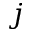Convert formula to latex. <formula><loc_0><loc_0><loc_500><loc_500>j</formula> 